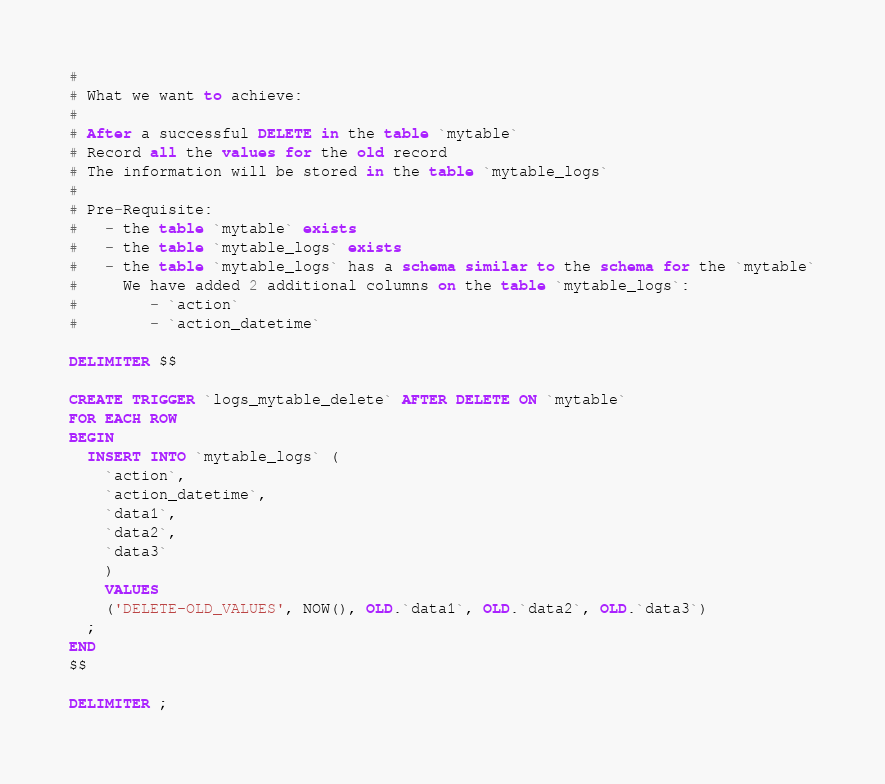<code> <loc_0><loc_0><loc_500><loc_500><_SQL_>#
# What we want to achieve:
#
# After a successful DELETE in the table `mytable`
# Record all the values for the old record
# The information will be stored in the table `mytable_logs`
#
# Pre-Requisite:
#   - the table `mytable` exists
#   - the table `mytable_logs` exists
#   - the table `mytable_logs` has a schema similar to the schema for the `mytable`
#     We have added 2 additional columns on the table `mytable_logs`:
#        - `action`
#        - `action_datetime`

DELIMITER $$

CREATE TRIGGER `logs_mytable_delete` AFTER DELETE ON `mytable`
FOR EACH ROW
BEGIN
  INSERT INTO `mytable_logs` (
    `action`, 
    `action_datetime`, 
    `data1`, 
    `data2`, 
    `data3`
    )
    VALUES
    ('DELETE-OLD_VALUES', NOW(), OLD.`data1`, OLD.`data2`, OLD.`data3`)
  ;
END
$$

DELIMITER ;</code> 